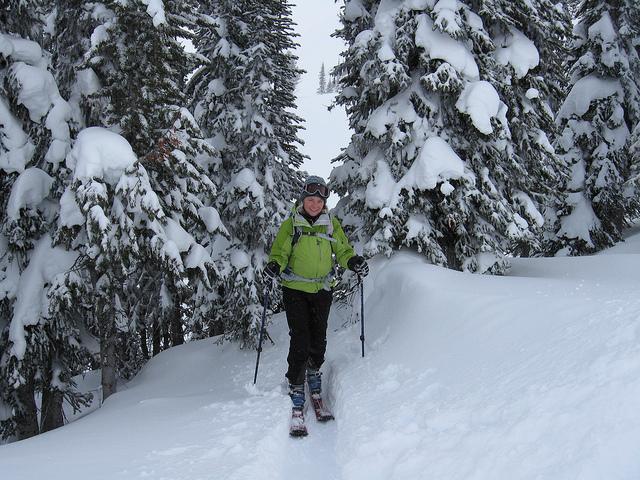How deep is the snow to the left of the ski pole?
Answer briefly. 2 feet. What kind of trees are those?
Be succinct. Pine. Has winter come?
Give a very brief answer. Yes. 